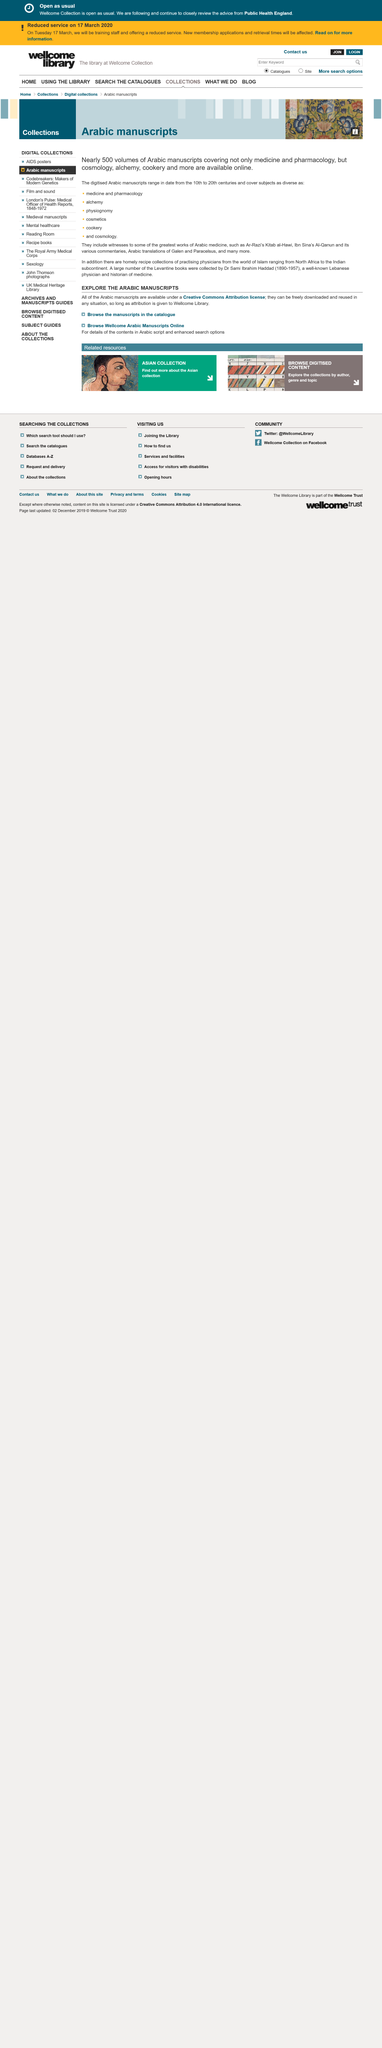Outline some significant characteristics in this image. Yes, Arabic manuscripts about cosmology are available online. It is estimated that nearly 500 volumes of Arabic manuscripts are currently available online. This page is about Arabic manuscripts, and they are about [insert information about Arabic manuscripts here]. 